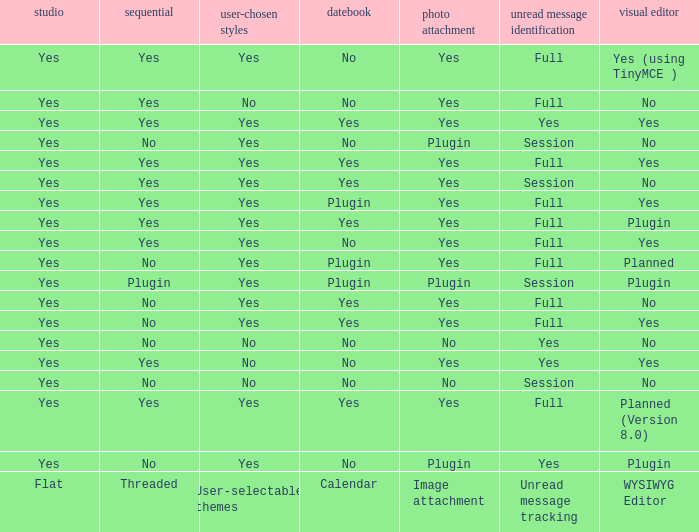Give me the full table as a dictionary. {'header': ['studio', 'sequential', 'user-chosen styles', 'datebook', 'photo attachment', 'unread message identification', 'visual editor'], 'rows': [['Yes', 'Yes', 'Yes', 'No', 'Yes', 'Full', 'Yes (using TinyMCE )'], ['Yes', 'Yes', 'No', 'No', 'Yes', 'Full', 'No'], ['Yes', 'Yes', 'Yes', 'Yes', 'Yes', 'Yes', 'Yes'], ['Yes', 'No', 'Yes', 'No', 'Plugin', 'Session', 'No'], ['Yes', 'Yes', 'Yes', 'Yes', 'Yes', 'Full', 'Yes'], ['Yes', 'Yes', 'Yes', 'Yes', 'Yes', 'Session', 'No'], ['Yes', 'Yes', 'Yes', 'Plugin', 'Yes', 'Full', 'Yes'], ['Yes', 'Yes', 'Yes', 'Yes', 'Yes', 'Full', 'Plugin'], ['Yes', 'Yes', 'Yes', 'No', 'Yes', 'Full', 'Yes'], ['Yes', 'No', 'Yes', 'Plugin', 'Yes', 'Full', 'Planned'], ['Yes', 'Plugin', 'Yes', 'Plugin', 'Plugin', 'Session', 'Plugin'], ['Yes', 'No', 'Yes', 'Yes', 'Yes', 'Full', 'No'], ['Yes', 'No', 'Yes', 'Yes', 'Yes', 'Full', 'Yes'], ['Yes', 'No', 'No', 'No', 'No', 'Yes', 'No'], ['Yes', 'Yes', 'No', 'No', 'Yes', 'Yes', 'Yes'], ['Yes', 'No', 'No', 'No', 'No', 'Session', 'No'], ['Yes', 'Yes', 'Yes', 'Yes', 'Yes', 'Full', 'Planned (Version 8.0)'], ['Yes', 'No', 'Yes', 'No', 'Plugin', 'Yes', 'Plugin'], ['Flat', 'Threaded', 'User-selectable themes', 'Calendar', 'Image attachment', 'Unread message tracking', 'WYSIWYG Editor']]} Which Image attachment has a Threaded of yes, and a Calendar of yes? Yes, Yes, Yes, Yes, Yes. 